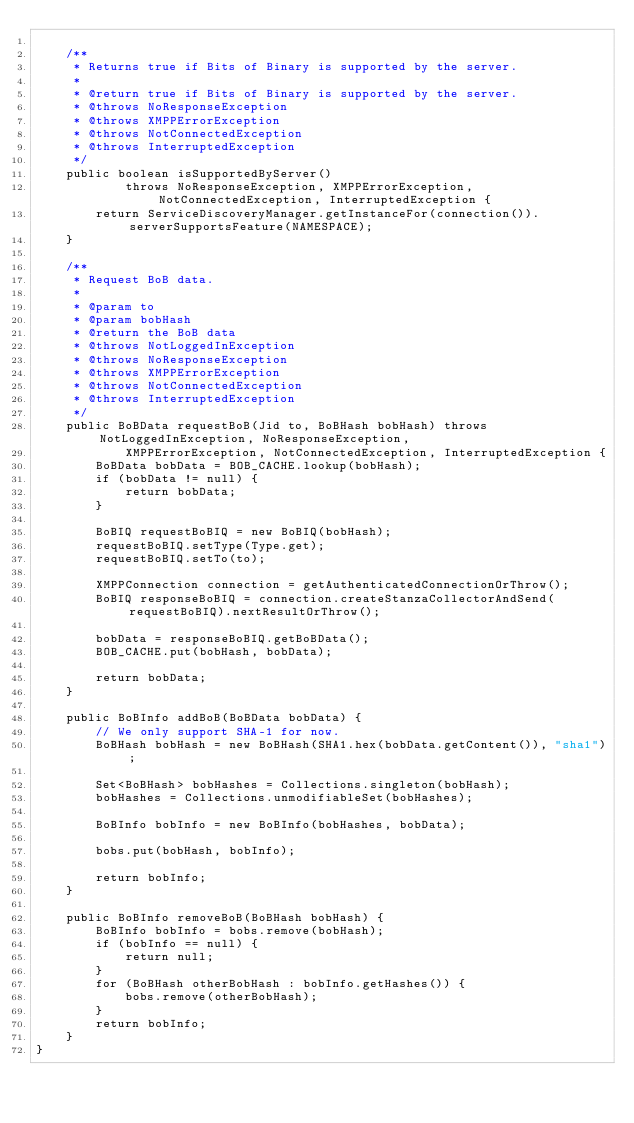Convert code to text. <code><loc_0><loc_0><loc_500><loc_500><_Java_>
    /**
     * Returns true if Bits of Binary is supported by the server.
     * 
     * @return true if Bits of Binary is supported by the server.
     * @throws NoResponseException
     * @throws XMPPErrorException
     * @throws NotConnectedException
     * @throws InterruptedException
     */
    public boolean isSupportedByServer()
            throws NoResponseException, XMPPErrorException, NotConnectedException, InterruptedException {
        return ServiceDiscoveryManager.getInstanceFor(connection()).serverSupportsFeature(NAMESPACE);
    }

    /**
     * Request BoB data.
     * 
     * @param to
     * @param bobHash
     * @return the BoB data
     * @throws NotLoggedInException
     * @throws NoResponseException
     * @throws XMPPErrorException
     * @throws NotConnectedException
     * @throws InterruptedException
     */
    public BoBData requestBoB(Jid to, BoBHash bobHash) throws NotLoggedInException, NoResponseException,
            XMPPErrorException, NotConnectedException, InterruptedException {
        BoBData bobData = BOB_CACHE.lookup(bobHash);
        if (bobData != null) {
            return bobData;
        }

        BoBIQ requestBoBIQ = new BoBIQ(bobHash);
        requestBoBIQ.setType(Type.get);
        requestBoBIQ.setTo(to);

        XMPPConnection connection = getAuthenticatedConnectionOrThrow();
        BoBIQ responseBoBIQ = connection.createStanzaCollectorAndSend(requestBoBIQ).nextResultOrThrow();

        bobData = responseBoBIQ.getBoBData();
        BOB_CACHE.put(bobHash, bobData);

        return bobData;
    }

    public BoBInfo addBoB(BoBData bobData) {
        // We only support SHA-1 for now.
        BoBHash bobHash = new BoBHash(SHA1.hex(bobData.getContent()), "sha1");

        Set<BoBHash> bobHashes = Collections.singleton(bobHash);
        bobHashes = Collections.unmodifiableSet(bobHashes);

        BoBInfo bobInfo = new BoBInfo(bobHashes, bobData);

        bobs.put(bobHash, bobInfo);

        return bobInfo;
    }

    public BoBInfo removeBoB(BoBHash bobHash) {
        BoBInfo bobInfo = bobs.remove(bobHash);
        if (bobInfo == null) {
            return null;
        }
        for (BoBHash otherBobHash : bobInfo.getHashes()) {
            bobs.remove(otherBobHash);
        }
        return bobInfo;
    }
}
</code> 